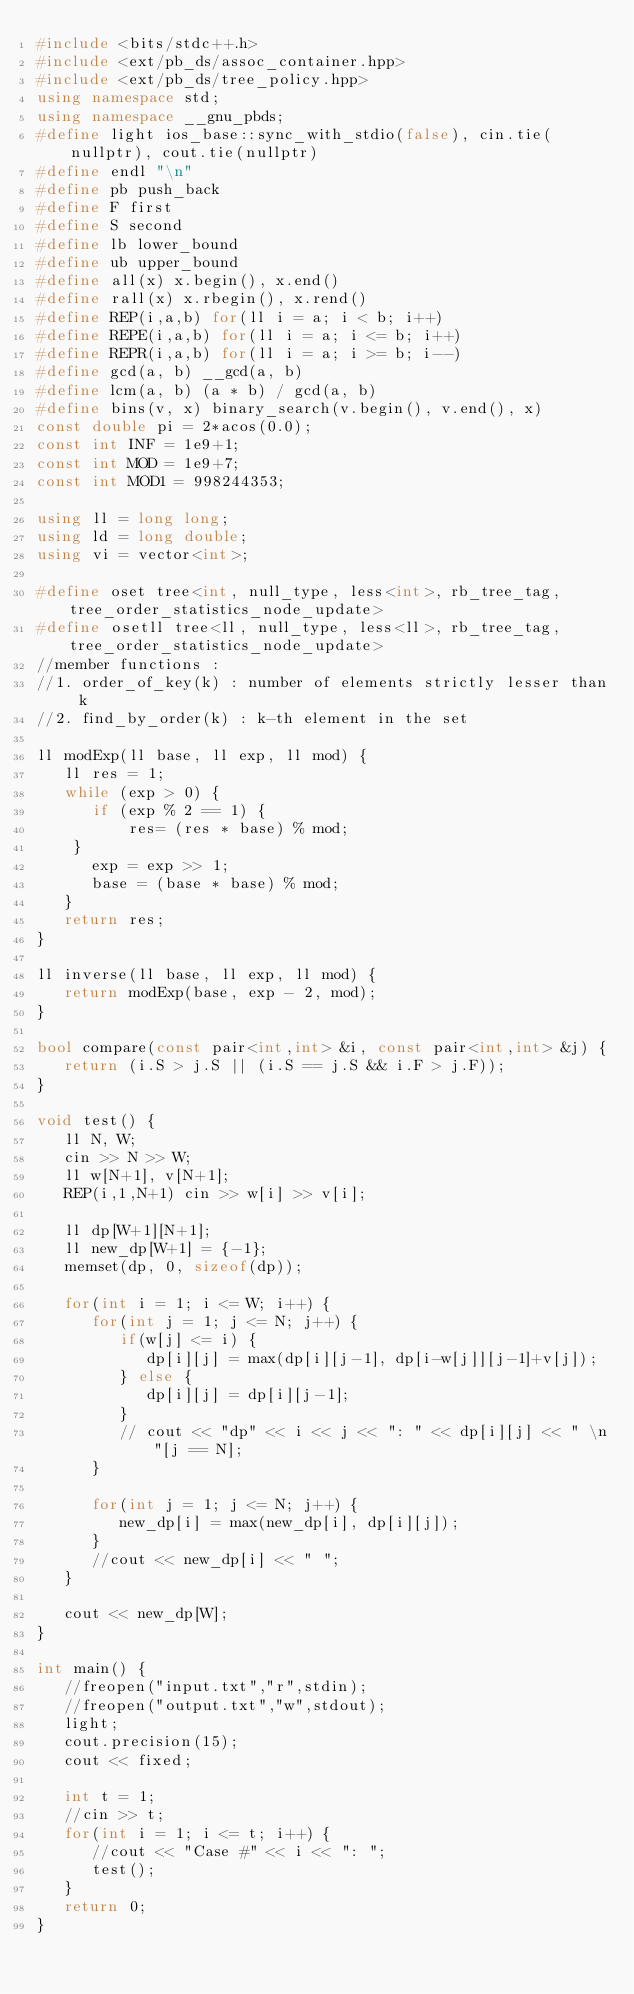Convert code to text. <code><loc_0><loc_0><loc_500><loc_500><_C++_>#include <bits/stdc++.h>
#include <ext/pb_ds/assoc_container.hpp>
#include <ext/pb_ds/tree_policy.hpp>
using namespace std;
using namespace __gnu_pbds;
#define light ios_base::sync_with_stdio(false), cin.tie(nullptr), cout.tie(nullptr)
#define endl "\n"
#define pb push_back
#define F first
#define S second
#define lb lower_bound
#define ub upper_bound
#define all(x) x.begin(), x.end()
#define rall(x) x.rbegin(), x.rend()
#define REP(i,a,b) for(ll i = a; i < b; i++)
#define REPE(i,a,b) for(ll i = a; i <= b; i++)
#define REPR(i,a,b) for(ll i = a; i >= b; i--)
#define gcd(a, b) __gcd(a, b)
#define lcm(a, b) (a * b) / gcd(a, b)
#define bins(v, x) binary_search(v.begin(), v.end(), x)
const double pi = 2*acos(0.0);
const int INF = 1e9+1;
const int MOD = 1e9+7;
const int MOD1 = 998244353;

using ll = long long;
using ld = long double;
using vi = vector<int>;

#define oset tree<int, null_type, less<int>, rb_tree_tag, tree_order_statistics_node_update>
#define osetll tree<ll, null_type, less<ll>, rb_tree_tag, tree_order_statistics_node_update>
//member functions :
//1. order_of_key(k) : number of elements strictly lesser than k
//2. find_by_order(k) : k-th element in the set
 
ll modExp(ll base, ll exp, ll mod) {
   ll res = 1;
   while (exp > 0) {
    	if (exp % 2 == 1) {
        	res= (res * base) % mod;
		}
      exp = exp >> 1;
      base = (base * base) % mod;
   }
   return res;
}

ll inverse(ll base, ll exp, ll mod) {
   return modExp(base, exp - 2, mod);
}

bool compare(const pair<int,int> &i, const pair<int,int> &j) {
   return (i.S > j.S || (i.S == j.S && i.F > j.F));
}

void test() {
   ll N, W;
   cin >> N >> W;
   ll w[N+1], v[N+1];
   REP(i,1,N+1) cin >> w[i] >> v[i];
   
   ll dp[W+1][N+1];
   ll new_dp[W+1] = {-1};
   memset(dp, 0, sizeof(dp));

   for(int i = 1; i <= W; i++) {
      for(int j = 1; j <= N; j++) {
         if(w[j] <= i) {
            dp[i][j] = max(dp[i][j-1], dp[i-w[j]][j-1]+v[j]);
         } else {
            dp[i][j] = dp[i][j-1];
         }
         // cout << "dp" << i << j << ": " << dp[i][j] << " \n"[j == N];
      }

      for(int j = 1; j <= N; j++) {
         new_dp[i] = max(new_dp[i], dp[i][j]);
      }
      //cout << new_dp[i] << " ";
   }

   cout << new_dp[W];
}

int main() {
   //freopen("input.txt","r",stdin);
   //freopen("output.txt","w",stdout);
   light;
   cout.precision(15);
   cout << fixed;

   int t = 1;
   //cin >> t;
   for(int i = 1; i <= t; i++) {
      //cout << "Case #" << i << ": ";
      test();
   }
   return 0;
}
</code> 